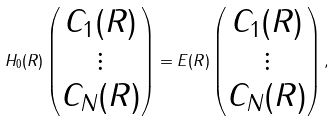<formula> <loc_0><loc_0><loc_500><loc_500>H _ { 0 } ( R ) \begin{pmatrix} C _ { 1 } ( R ) \\ \vdots \\ C _ { N } ( R ) \end{pmatrix} = E ( R ) \begin{pmatrix} C _ { 1 } ( R ) \\ \vdots \\ C _ { N } ( R ) \end{pmatrix} ,</formula> 